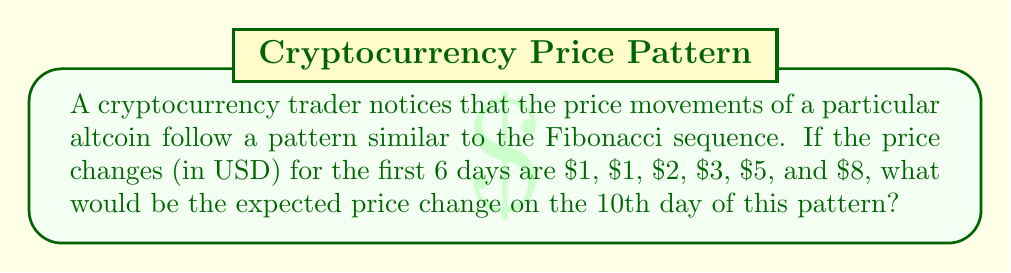Teach me how to tackle this problem. To solve this problem, we need to follow these steps:

1. Recognize the Fibonacci sequence:
   The given sequence (1, 1, 2, 3, 5, 8) follows the Fibonacci pattern where each number is the sum of the two preceding ones.

2. Extend the sequence to the 10th term:
   $$F_1 = 1$$
   $$F_2 = 1$$
   $$F_3 = 1 + 1 = 2$$
   $$F_4 = 1 + 2 = 3$$
   $$F_5 = 2 + 3 = 5$$
   $$F_6 = 3 + 5 = 8$$
   $$F_7 = 5 + 8 = 13$$
   $$F_8 = 8 + 13 = 21$$
   $$F_9 = 13 + 21 = 34$$
   $$F_{10} = 21 + 34 = 55$$

3. The 10th term in the sequence is 55, which represents the expected price change on the 10th day.
Answer: $55 